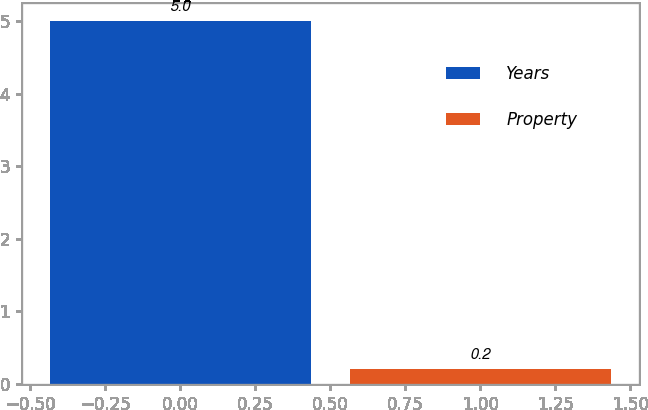Convert chart. <chart><loc_0><loc_0><loc_500><loc_500><bar_chart><fcel>Years<fcel>Property<nl><fcel>5<fcel>0.2<nl></chart> 